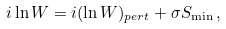<formula> <loc_0><loc_0><loc_500><loc_500>i \ln W = i ( \ln W ) _ { p e r t } + \sigma S _ { \min } \, ,</formula> 